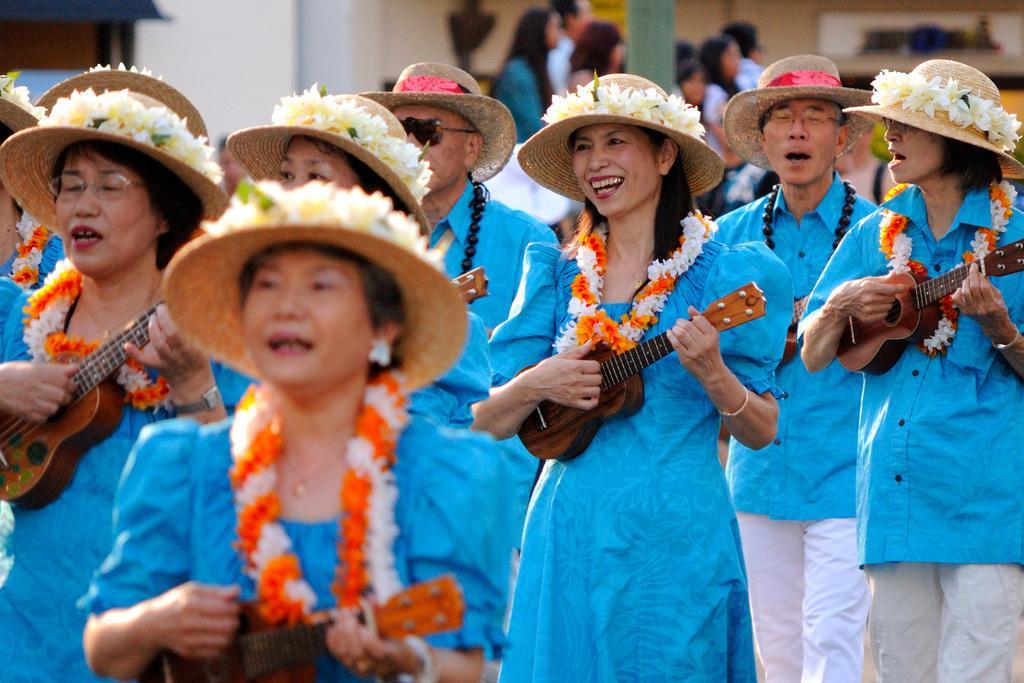How would you summarize this image in a sentence or two? In this image I can see a group of people holding a guitar in their hands, wearing blue tops, hats, flowers on hats and garlands. I can see some more people standing far behind them. 